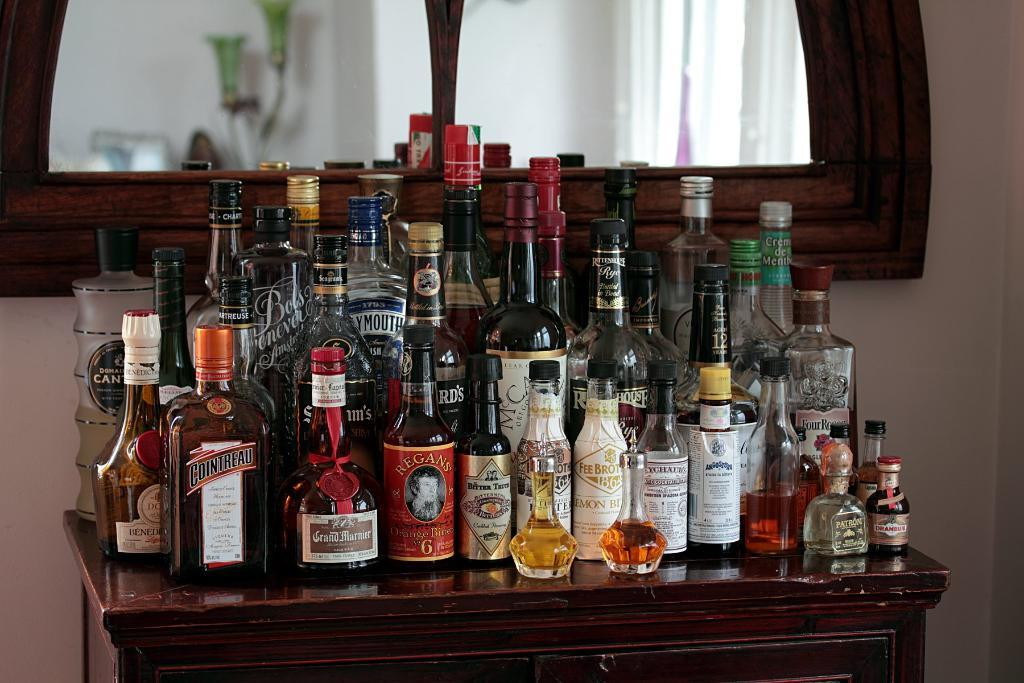What objects are on the table in the image? There are bottles on a table in the image. What is located behind the bottles on the table? There is a big mirror behind the bottles in the image. What color do the table and mirror appear to have? The mirror and table have a brownish color. How many giants can be seen in the image? There are no giants present in the image. What type of kitty is sitting on the table next to the bottles? There is no kitty present in the image. 